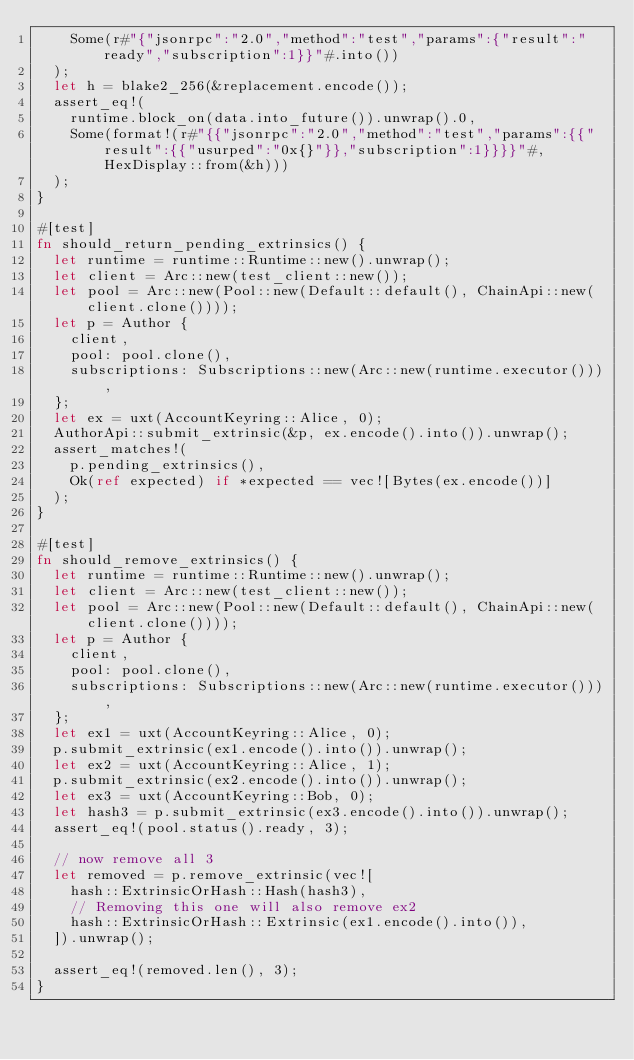<code> <loc_0><loc_0><loc_500><loc_500><_Rust_>		Some(r#"{"jsonrpc":"2.0","method":"test","params":{"result":"ready","subscription":1}}"#.into())
	);
	let h = blake2_256(&replacement.encode());
	assert_eq!(
		runtime.block_on(data.into_future()).unwrap().0,
		Some(format!(r#"{{"jsonrpc":"2.0","method":"test","params":{{"result":{{"usurped":"0x{}"}},"subscription":1}}}}"#, HexDisplay::from(&h)))
	);
}

#[test]
fn should_return_pending_extrinsics() {
	let runtime = runtime::Runtime::new().unwrap();
	let client = Arc::new(test_client::new());
	let pool = Arc::new(Pool::new(Default::default(), ChainApi::new(client.clone())));
	let p = Author {
		client,
		pool: pool.clone(),
		subscriptions: Subscriptions::new(Arc::new(runtime.executor())),
	};
	let ex = uxt(AccountKeyring::Alice, 0);
	AuthorApi::submit_extrinsic(&p, ex.encode().into()).unwrap();
 	assert_matches!(
		p.pending_extrinsics(),
		Ok(ref expected) if *expected == vec![Bytes(ex.encode())]
	);
}

#[test]
fn should_remove_extrinsics() {
	let runtime = runtime::Runtime::new().unwrap();
	let client = Arc::new(test_client::new());
	let pool = Arc::new(Pool::new(Default::default(), ChainApi::new(client.clone())));
	let p = Author {
		client,
		pool: pool.clone(),
		subscriptions: Subscriptions::new(Arc::new(runtime.executor())),
	};
	let ex1 = uxt(AccountKeyring::Alice, 0);
	p.submit_extrinsic(ex1.encode().into()).unwrap();
	let ex2 = uxt(AccountKeyring::Alice, 1);
	p.submit_extrinsic(ex2.encode().into()).unwrap();
	let ex3 = uxt(AccountKeyring::Bob, 0);
	let hash3 = p.submit_extrinsic(ex3.encode().into()).unwrap();
	assert_eq!(pool.status().ready, 3);

	// now remove all 3
	let removed = p.remove_extrinsic(vec![
		hash::ExtrinsicOrHash::Hash(hash3),
		// Removing this one will also remove ex2
		hash::ExtrinsicOrHash::Extrinsic(ex1.encode().into()),
	]).unwrap();

 	assert_eq!(removed.len(), 3);
}
</code> 